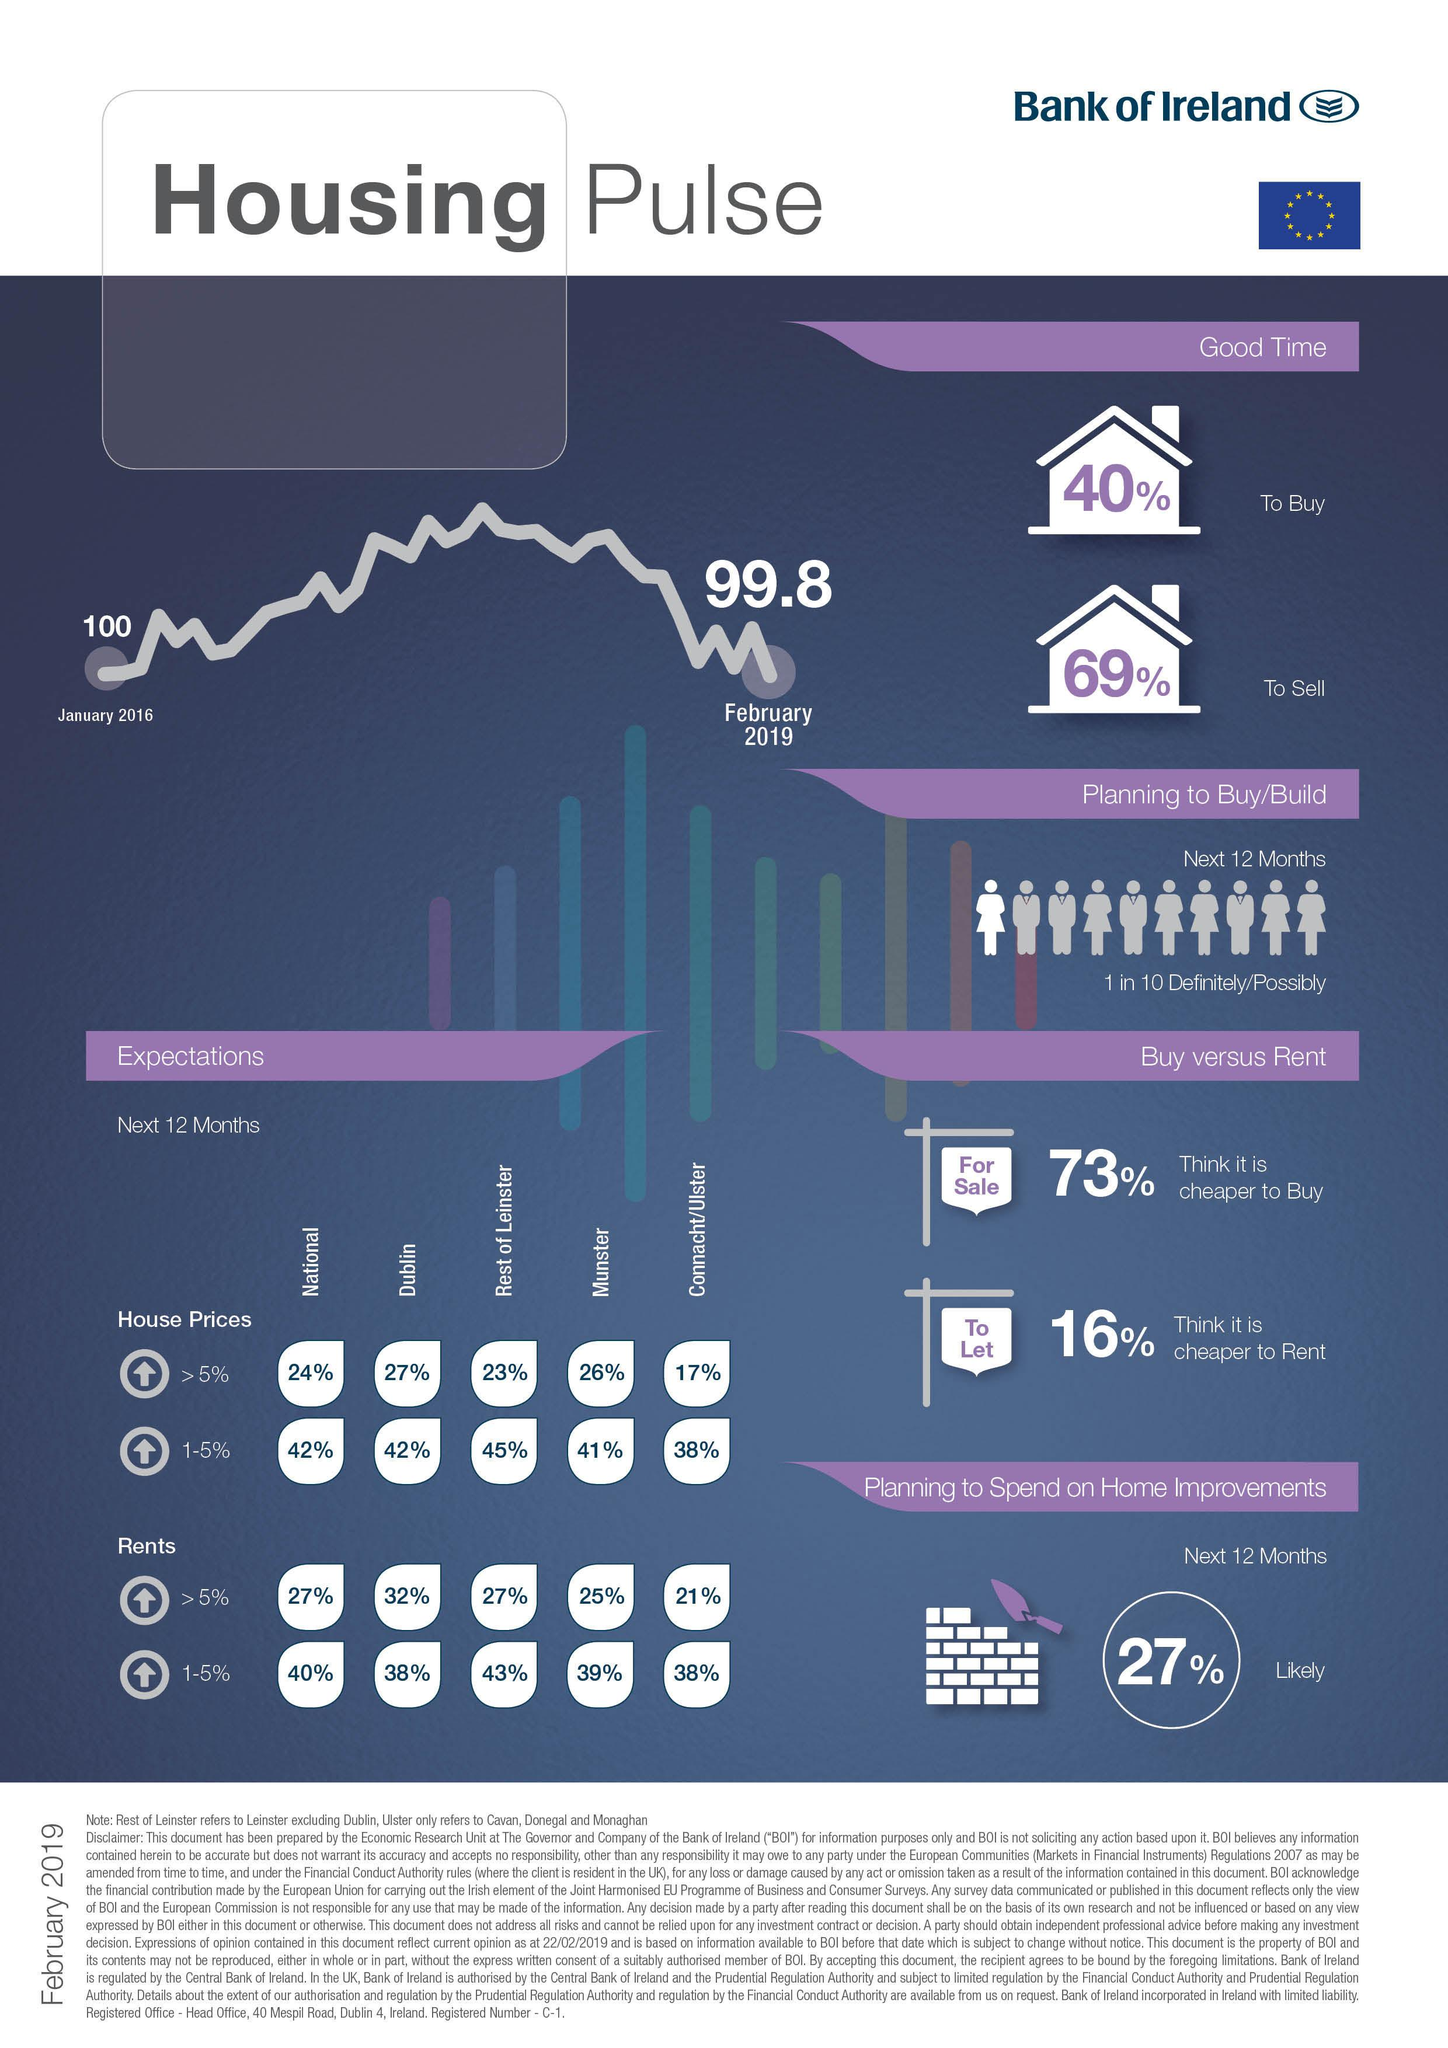Give some essential details in this illustration. The banner beside the 73% depicts the phrase 'For Sale' in writing. According to the given information, it is expected that the rental price in Dublin will rise by approximately 38% if the interest rate increases by 1-5%. According to the data, 29% of people believe that it is a good time to buy, while 29% believe that it is a good time to sell. The housing market has seen a decline in recent times. According to estimates, the rental price in the rest of Leinster is expected to rise by 1-5% in the coming years. 